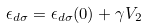Convert formula to latex. <formula><loc_0><loc_0><loc_500><loc_500>\epsilon _ { d \sigma } = \epsilon _ { d \sigma } ( 0 ) + \gamma V _ { 2 }</formula> 